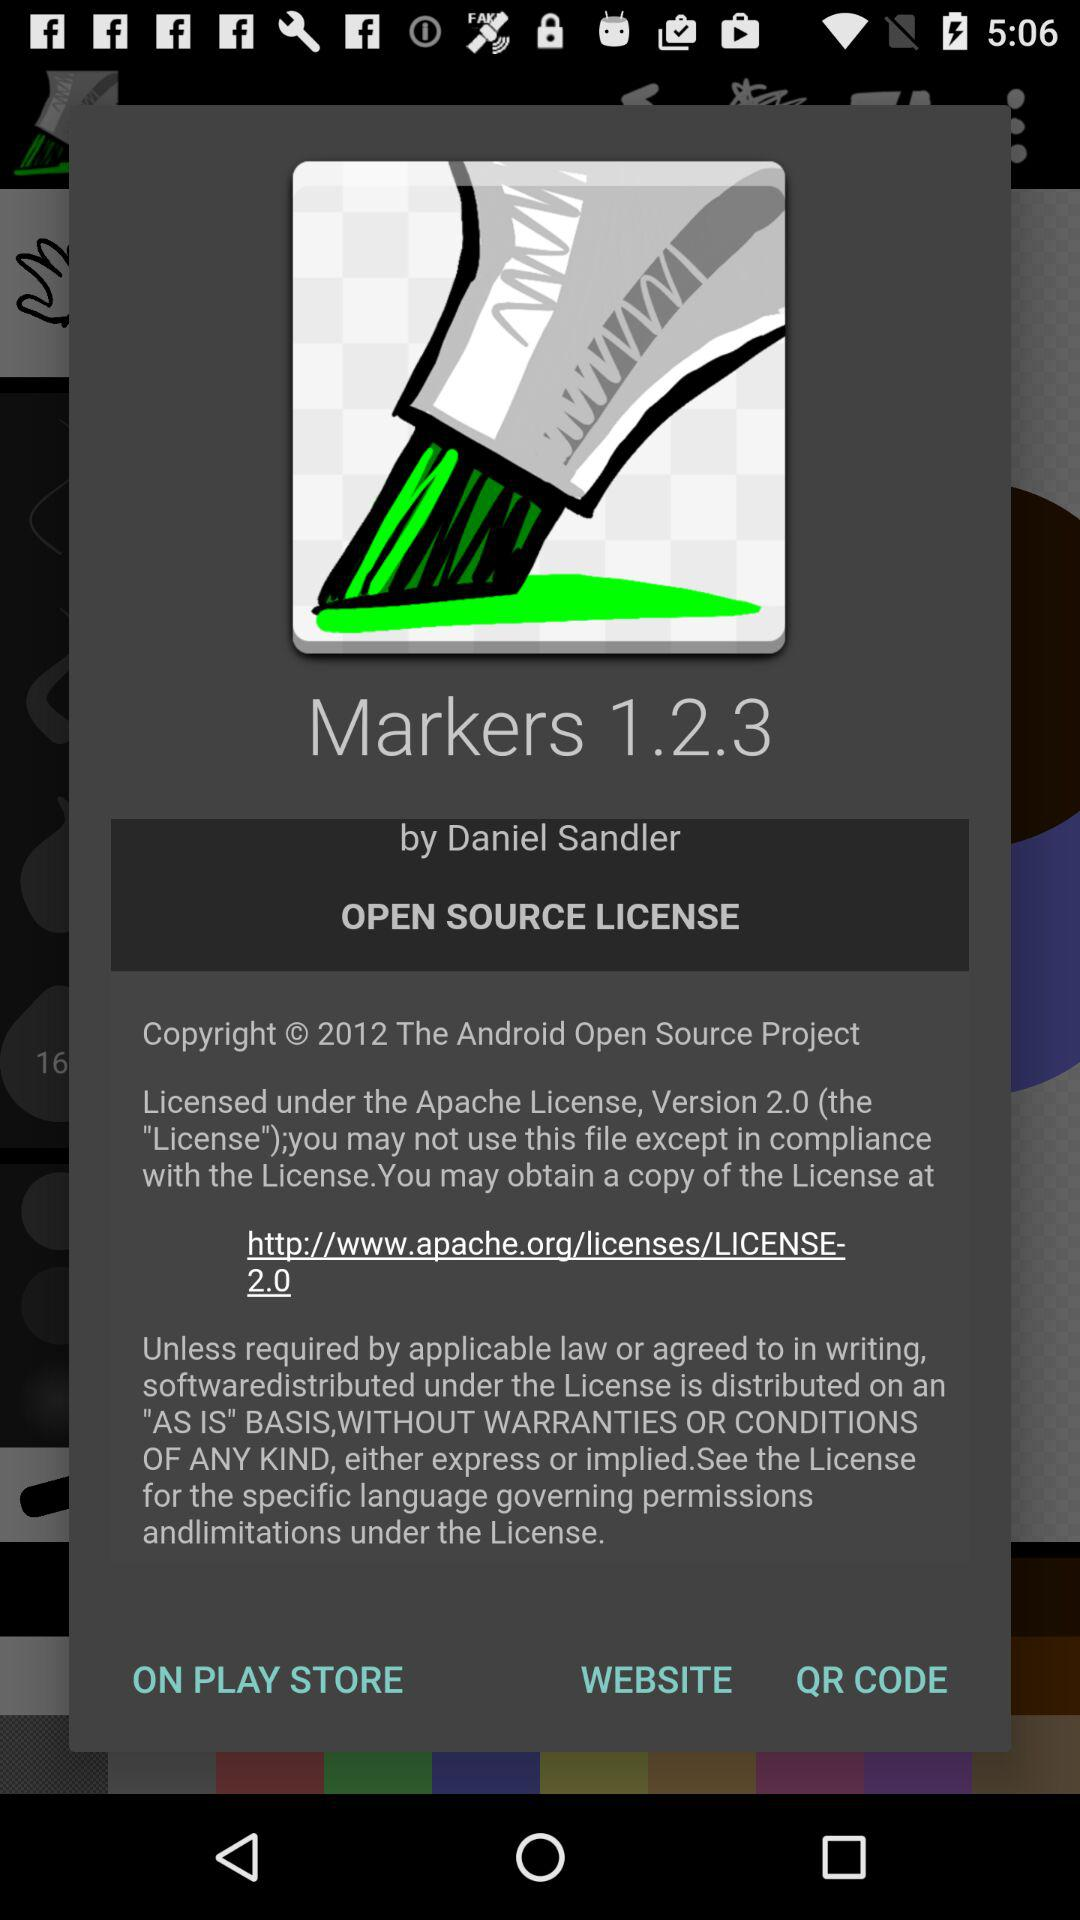What is the version? The version is 2.0. 